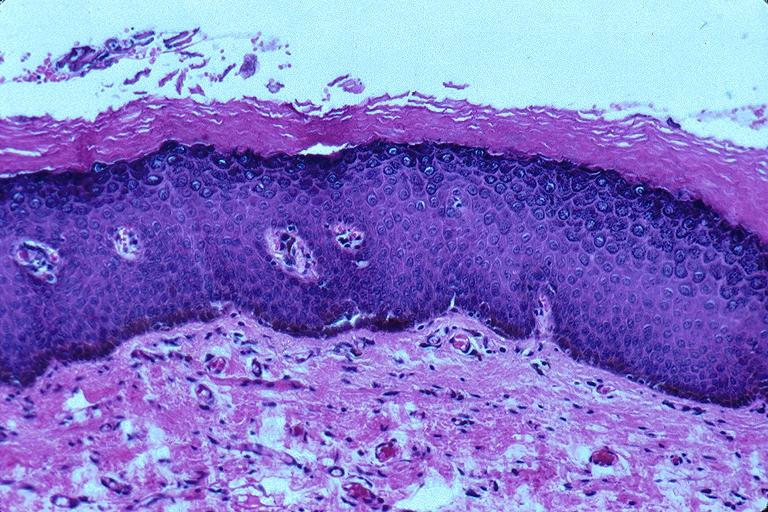where is this?
Answer the question using a single word or phrase. Oral 